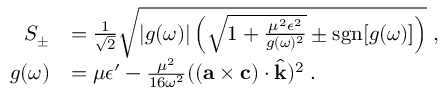<formula> <loc_0><loc_0><loc_500><loc_500>\begin{array} { r l } { S _ { \pm } } & { = \frac { 1 } { \sqrt { 2 } } \sqrt { | g ( \omega ) | \left ( \sqrt { 1 + \frac { \mu ^ { 2 } \epsilon ^ { 2 } } { g ( \omega ) ^ { 2 } } } \pm s g n [ g ( \omega ) ] \right ) } \, , } \\ { g ( \omega ) } & { = \mu \epsilon ^ { \prime } - \frac { \mu ^ { 2 } } { 1 6 \omega ^ { 2 } } ( ( { a } \times { c } ) \cdot \hat { k } ) ^ { 2 } \, . } \end{array}</formula> 